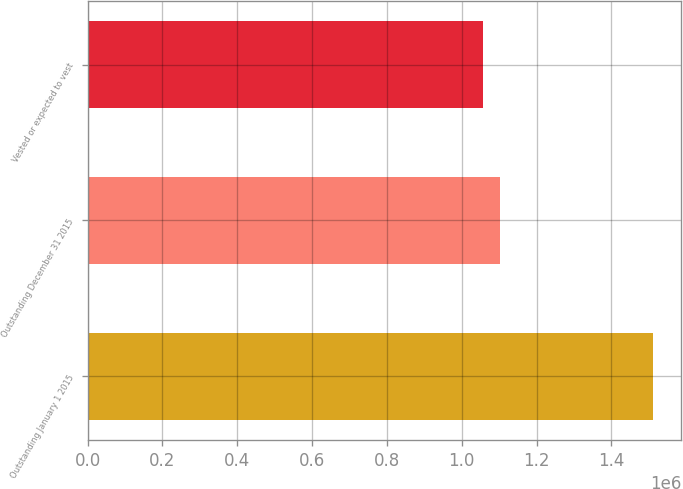<chart> <loc_0><loc_0><loc_500><loc_500><bar_chart><fcel>Outstanding January 1 2015<fcel>Outstanding December 31 2015<fcel>Vested or expected to vest<nl><fcel>1.51092e+06<fcel>1.10335e+06<fcel>1.05806e+06<nl></chart> 